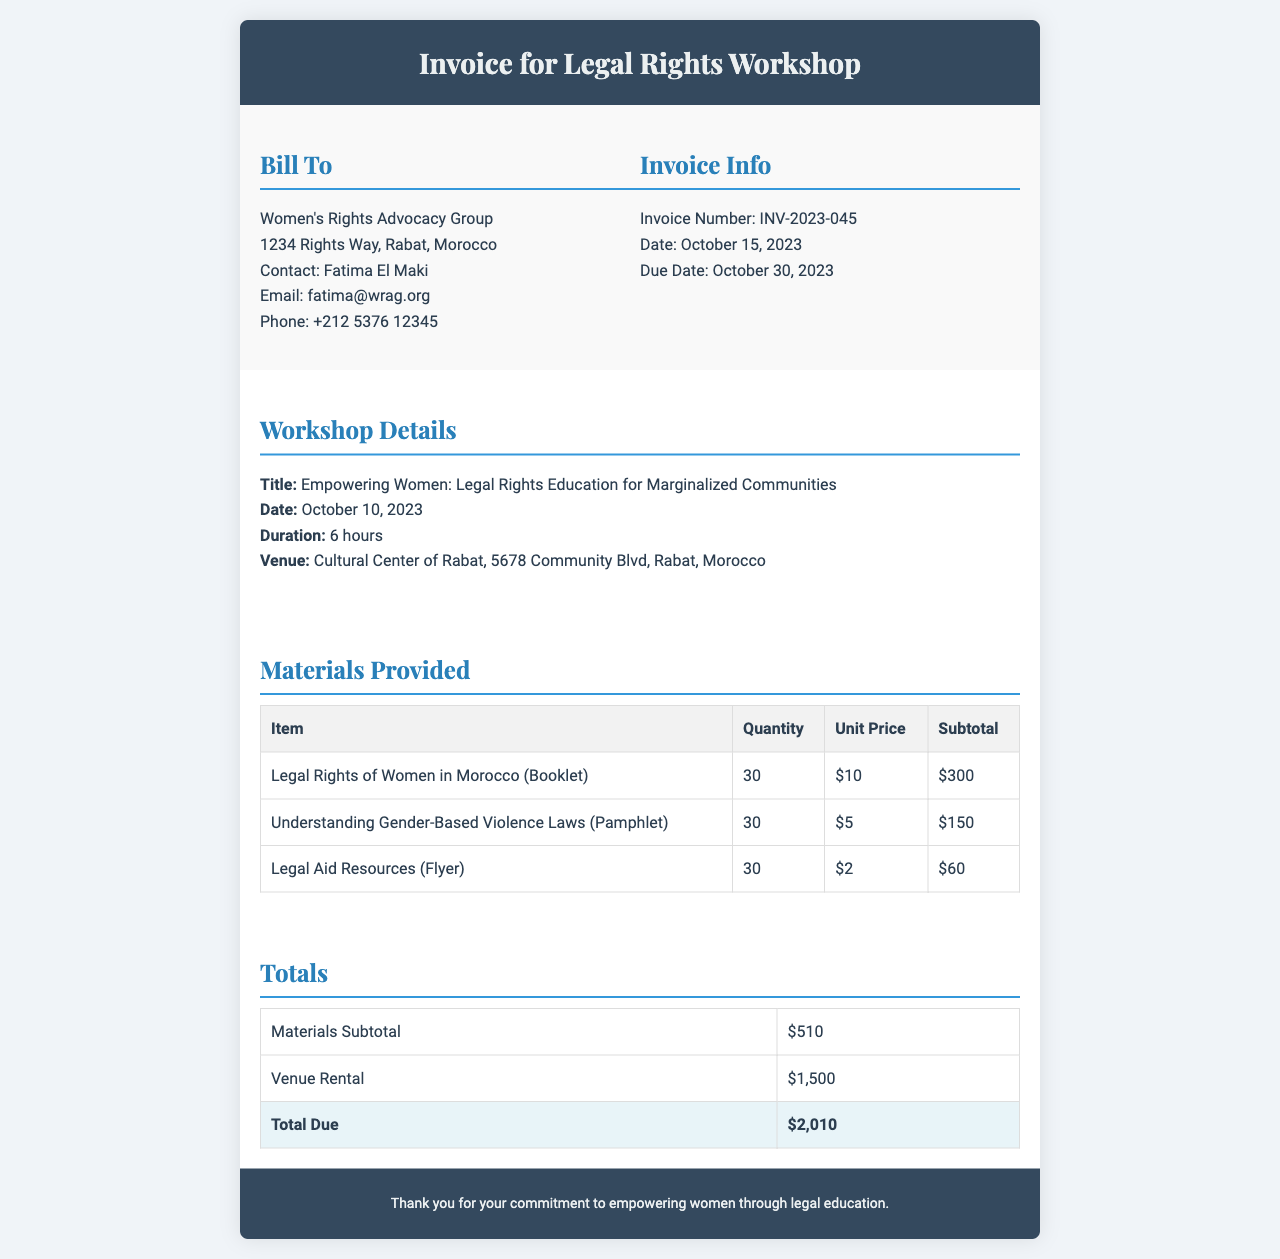what is the title of the workshop? The title of the workshop is located in the workshop details section of the invoice.
Answer: Empowering Women: Legal Rights Education for Marginalized Communities who is the contact person for the billing entity? The contact person for the billing entity is mentioned under the bill to section.
Answer: Fatima El Maki what is the total due amount? The total due amount is found in the totals section of the invoice.
Answer: $2,010 when is the invoice due date? The due date is specified in the invoice info section.
Answer: October 30, 2023 how many copies of the booklet "Legal Rights of Women in Morocco" were provided? The quantity of the booklet can be found in the materials provided table.
Answer: 30 what is the venue for the workshop? The venue is listed in the workshop details section of the invoice.
Answer: Cultural Center of Rabat how long was the workshop? The duration of the workshop is stated in the workshop details.
Answer: 6 hours what is the subtotal for materials provided? The subtotal for materials provided is detailed in the totals section of the invoice.
Answer: $510 